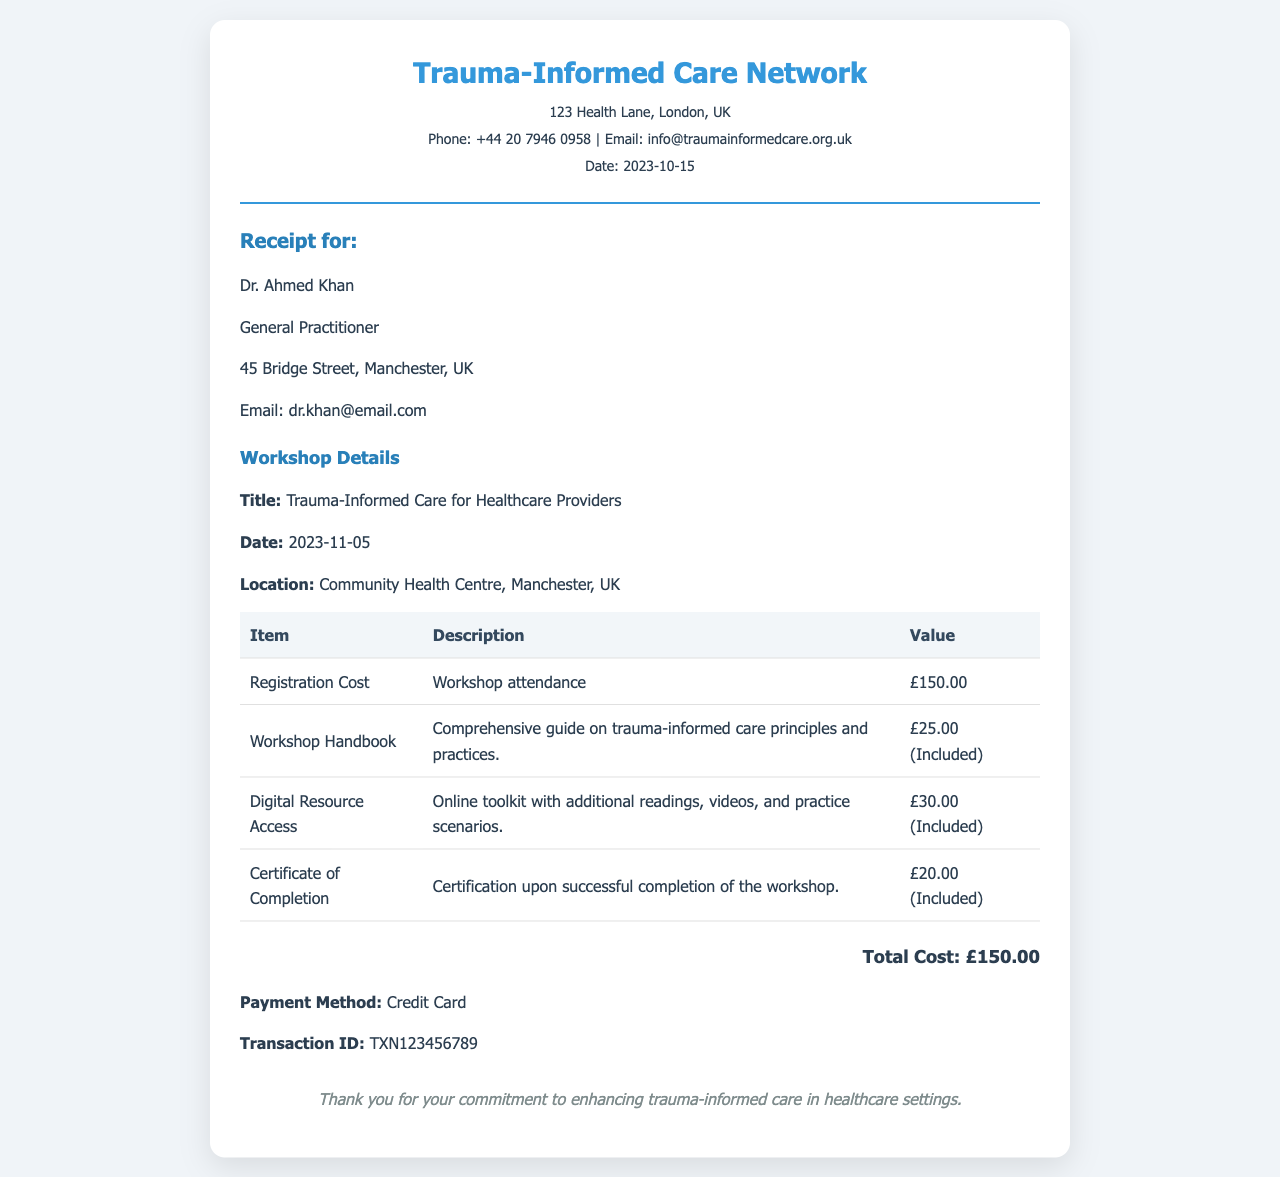What is the date of the workshop? The workshop is scheduled for November 5, 2023, as mentioned in the details section.
Answer: 2023-11-05 What is the total cost of the registration? The total cost displayed at the bottom of the receipt summarizes the expenses related to registration, which is £150.00.
Answer: £150.00 Who is the recipient of this receipt? The receipt identifies Dr. Ahmed Khan as the recipient in the designated area for recipient information.
Answer: Dr. Ahmed Khan How much does the workshop handbook cost? The workshop handbook is noted to be included with the registration cost, listed as £25.00.
Answer: £25.00 (Included) What payment method was used? The receipt specifies that a credit card was used as the payment method for the workshop registration.
Answer: Credit Card What organization is hosting the workshop? The header of the receipt indicates that the Trauma-Informed Care Network is organizing the workshop.
Answer: Trauma-Informed Care Network What is included with the registration besides the attendance? The receipt lists a workshop handbook, digital resource access, and a certificate of completion as included items.
Answer: Handbook, Digital Resource Access, Certificate of Completion What is the transaction ID for this payment? The transaction ID is provided in the details of the payment section as TXN123456789.
Answer: TXN123456789 